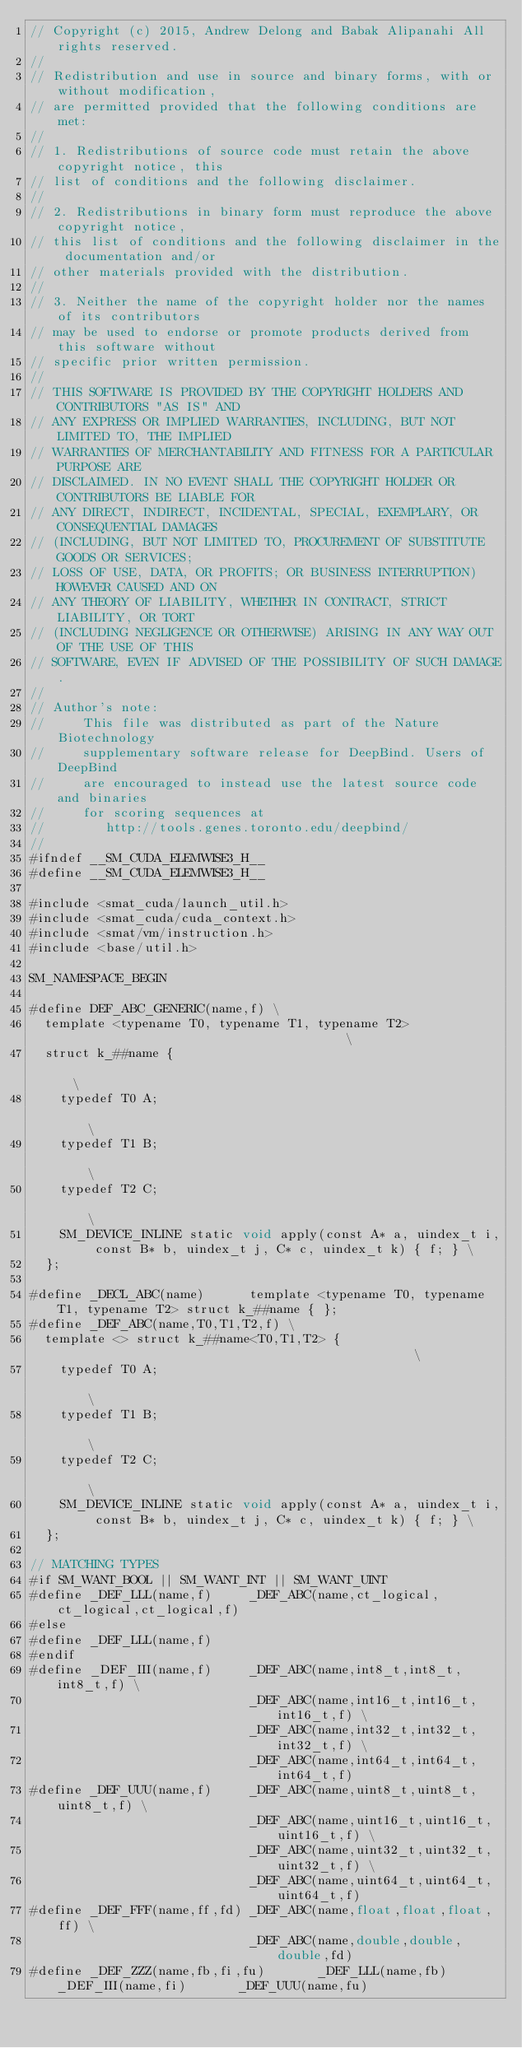<code> <loc_0><loc_0><loc_500><loc_500><_Cuda_>// Copyright (c) 2015, Andrew Delong and Babak Alipanahi All rights reserved.
// 
// Redistribution and use in source and binary forms, with or without modification,
// are permitted provided that the following conditions are met:
// 
// 1. Redistributions of source code must retain the above copyright notice, this
// list of conditions and the following disclaimer.
// 
// 2. Redistributions in binary form must reproduce the above copyright notice,
// this list of conditions and the following disclaimer in the documentation and/or
// other materials provided with the distribution.
// 
// 3. Neither the name of the copyright holder nor the names of its contributors
// may be used to endorse or promote products derived from this software without
// specific prior written permission.
// 
// THIS SOFTWARE IS PROVIDED BY THE COPYRIGHT HOLDERS AND CONTRIBUTORS "AS IS" AND
// ANY EXPRESS OR IMPLIED WARRANTIES, INCLUDING, BUT NOT LIMITED TO, THE IMPLIED
// WARRANTIES OF MERCHANTABILITY AND FITNESS FOR A PARTICULAR PURPOSE ARE
// DISCLAIMED. IN NO EVENT SHALL THE COPYRIGHT HOLDER OR CONTRIBUTORS BE LIABLE FOR
// ANY DIRECT, INDIRECT, INCIDENTAL, SPECIAL, EXEMPLARY, OR CONSEQUENTIAL DAMAGES
// (INCLUDING, BUT NOT LIMITED TO, PROCUREMENT OF SUBSTITUTE GOODS OR SERVICES;
// LOSS OF USE, DATA, OR PROFITS; OR BUSINESS INTERRUPTION) HOWEVER CAUSED AND ON
// ANY THEORY OF LIABILITY, WHETHER IN CONTRACT, STRICT LIABILITY, OR TORT
// (INCLUDING NEGLIGENCE OR OTHERWISE) ARISING IN ANY WAY OUT OF THE USE OF THIS
// SOFTWARE, EVEN IF ADVISED OF THE POSSIBILITY OF SUCH DAMAGE.
// 
// Author's note: 
//     This file was distributed as part of the Nature Biotechnology 
//     supplementary software release for DeepBind. Users of DeepBind
//     are encouraged to instead use the latest source code and binaries 
//     for scoring sequences at
//        http://tools.genes.toronto.edu/deepbind/
// 
#ifndef __SM_CUDA_ELEMWISE3_H__
#define __SM_CUDA_ELEMWISE3_H__

#include <smat_cuda/launch_util.h>
#include <smat_cuda/cuda_context.h>
#include <smat/vm/instruction.h>
#include <base/util.h>

SM_NAMESPACE_BEGIN

#define DEF_ABC_GENERIC(name,f) \
	template <typename T0, typename T1, typename T2>                                     \
	struct k_##name {                                                                    \
		typedef T0 A;                                                                    \
		typedef T1 B;                                                                    \
		typedef T2 C;                                                                    \
		SM_DEVICE_INLINE static void apply(const A* a, uindex_t i, const B* b, uindex_t j, C* c, uindex_t k) { f; } \
	};

#define _DECL_ABC(name)      template <typename T0, typename T1, typename T2> struct k_##name { };
#define _DEF_ABC(name,T0,T1,T2,f) \
	template <> struct k_##name<T0,T1,T2> {                                              \
		typedef T0 A;                                                                    \
		typedef T1 B;                                                                    \
		typedef T2 C;                                                                    \
		SM_DEVICE_INLINE static void apply(const A* a, uindex_t i, const B* b, uindex_t j, C* c, uindex_t k) { f; } \
	};

// MATCHING TYPES
#if SM_WANT_BOOL || SM_WANT_INT || SM_WANT_UINT
#define _DEF_LLL(name,f)     _DEF_ABC(name,ct_logical,ct_logical,ct_logical,f)
#else
#define _DEF_LLL(name,f)     
#endif
#define _DEF_III(name,f)     _DEF_ABC(name,int8_t,int8_t,int8_t,f) \
                             _DEF_ABC(name,int16_t,int16_t,int16_t,f) \
                             _DEF_ABC(name,int32_t,int32_t,int32_t,f) \
                             _DEF_ABC(name,int64_t,int64_t,int64_t,f) 
#define _DEF_UUU(name,f)     _DEF_ABC(name,uint8_t,uint8_t,uint8_t,f) \
                             _DEF_ABC(name,uint16_t,uint16_t,uint16_t,f) \
                             _DEF_ABC(name,uint32_t,uint32_t,uint32_t,f) \
                             _DEF_ABC(name,uint64_t,uint64_t,uint64_t,f) 
#define _DEF_FFF(name,ff,fd) _DEF_ABC(name,float,float,float,ff) \
                             _DEF_ABC(name,double,double,double,fd)
#define _DEF_ZZZ(name,fb,fi,fu)       _DEF_LLL(name,fb)    _DEF_III(name,fi)       _DEF_UUU(name,fu)</code> 